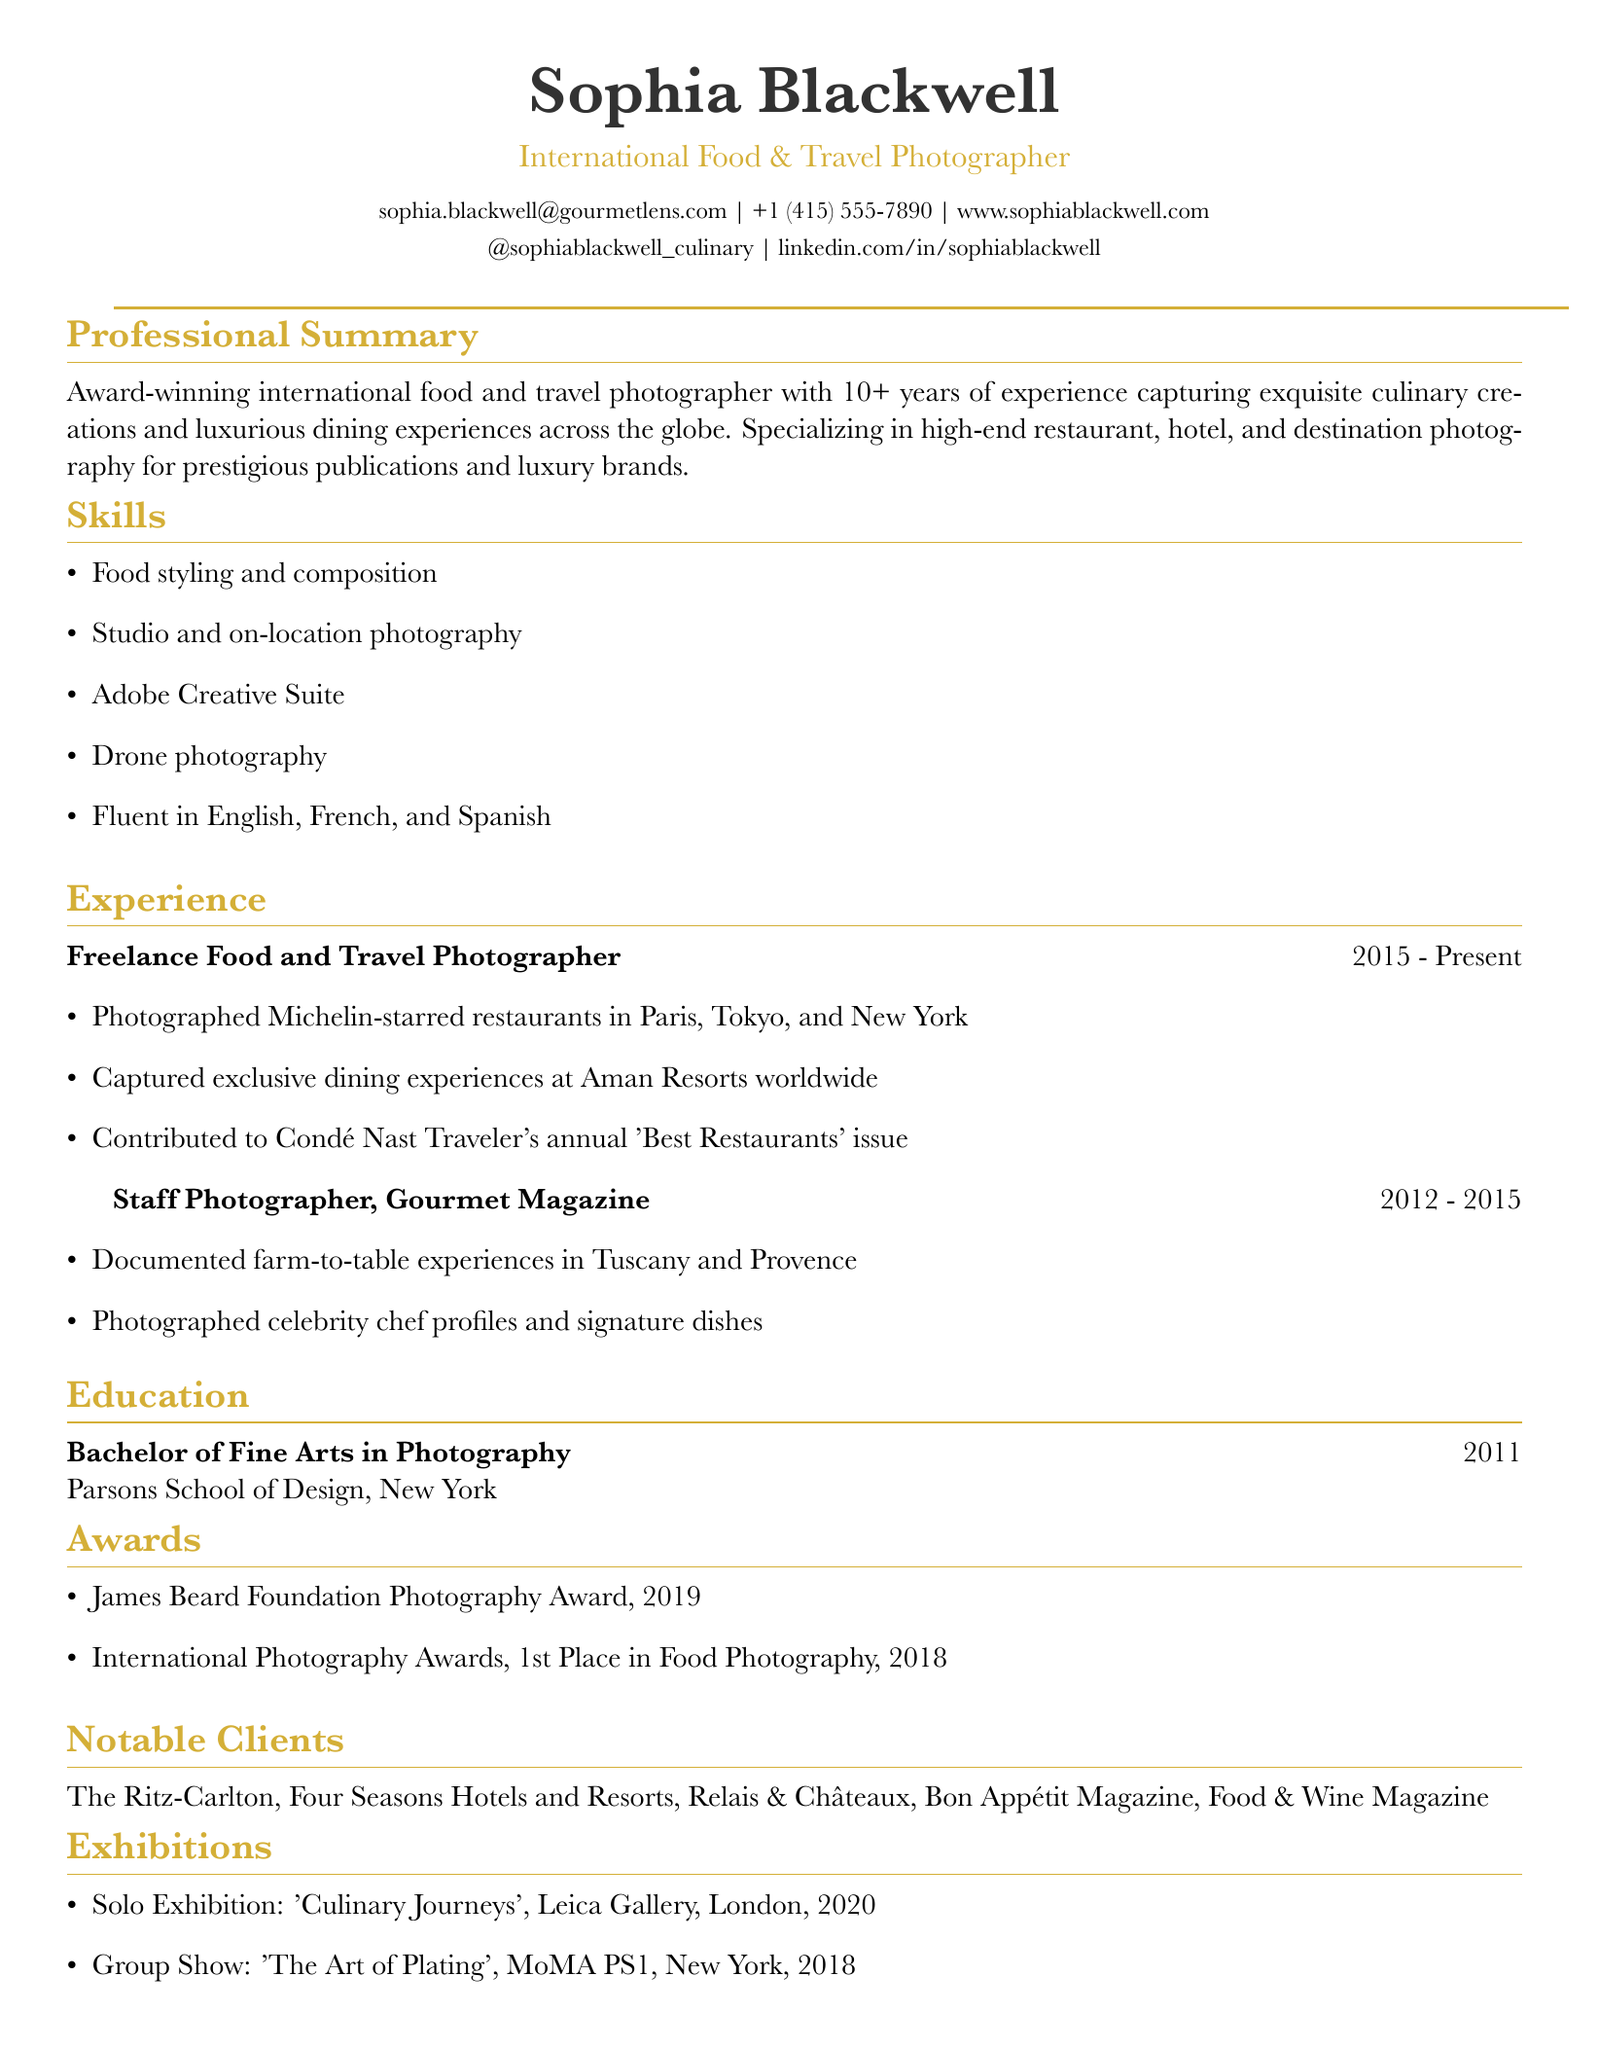What is the name of the photographer? The name of the photographer is presented at the top of the document under personal information.
Answer: Sophia Blackwell What is Sophia Blackwell's email address? The email address is found in the contact information section of the CV.
Answer: sophia.blackwell@gourmetlens.com How many years of experience does Sophia Blackwell have? The number of years of experience is mentioned in the professional summary section.
Answer: 10+ Which prestigious award did she win in 2019? The specific award is listed under the awards section of the CV.
Answer: James Beard Foundation Photography Award Where did she receive her Bachelor of Fine Arts degree? The educational institution is provided in the education section of the CV.
Answer: Parsons School of Design, New York What type of photography does Sophia specialize in? The specialization is mentioned in the professional summary at the beginning of the document.
Answer: High-end restaurant, hotel, and destination photography Which notable clients are listed in her CV? The notable clients are enumerated in a specific section dedicated to them in the CV.
Answer: The Ritz-Carlton, Four Seasons Hotels and Resorts, Relais & Châteaux, Bon Appétit Magazine, Food & Wine Magazine In which year did she hold her solo exhibition? The year of her solo exhibition is detailed in the exhibitions section of the CV.
Answer: 2020 What role did she hold at Gourmet Magazine? The role is specified in the experience section.
Answer: Staff Photographer 